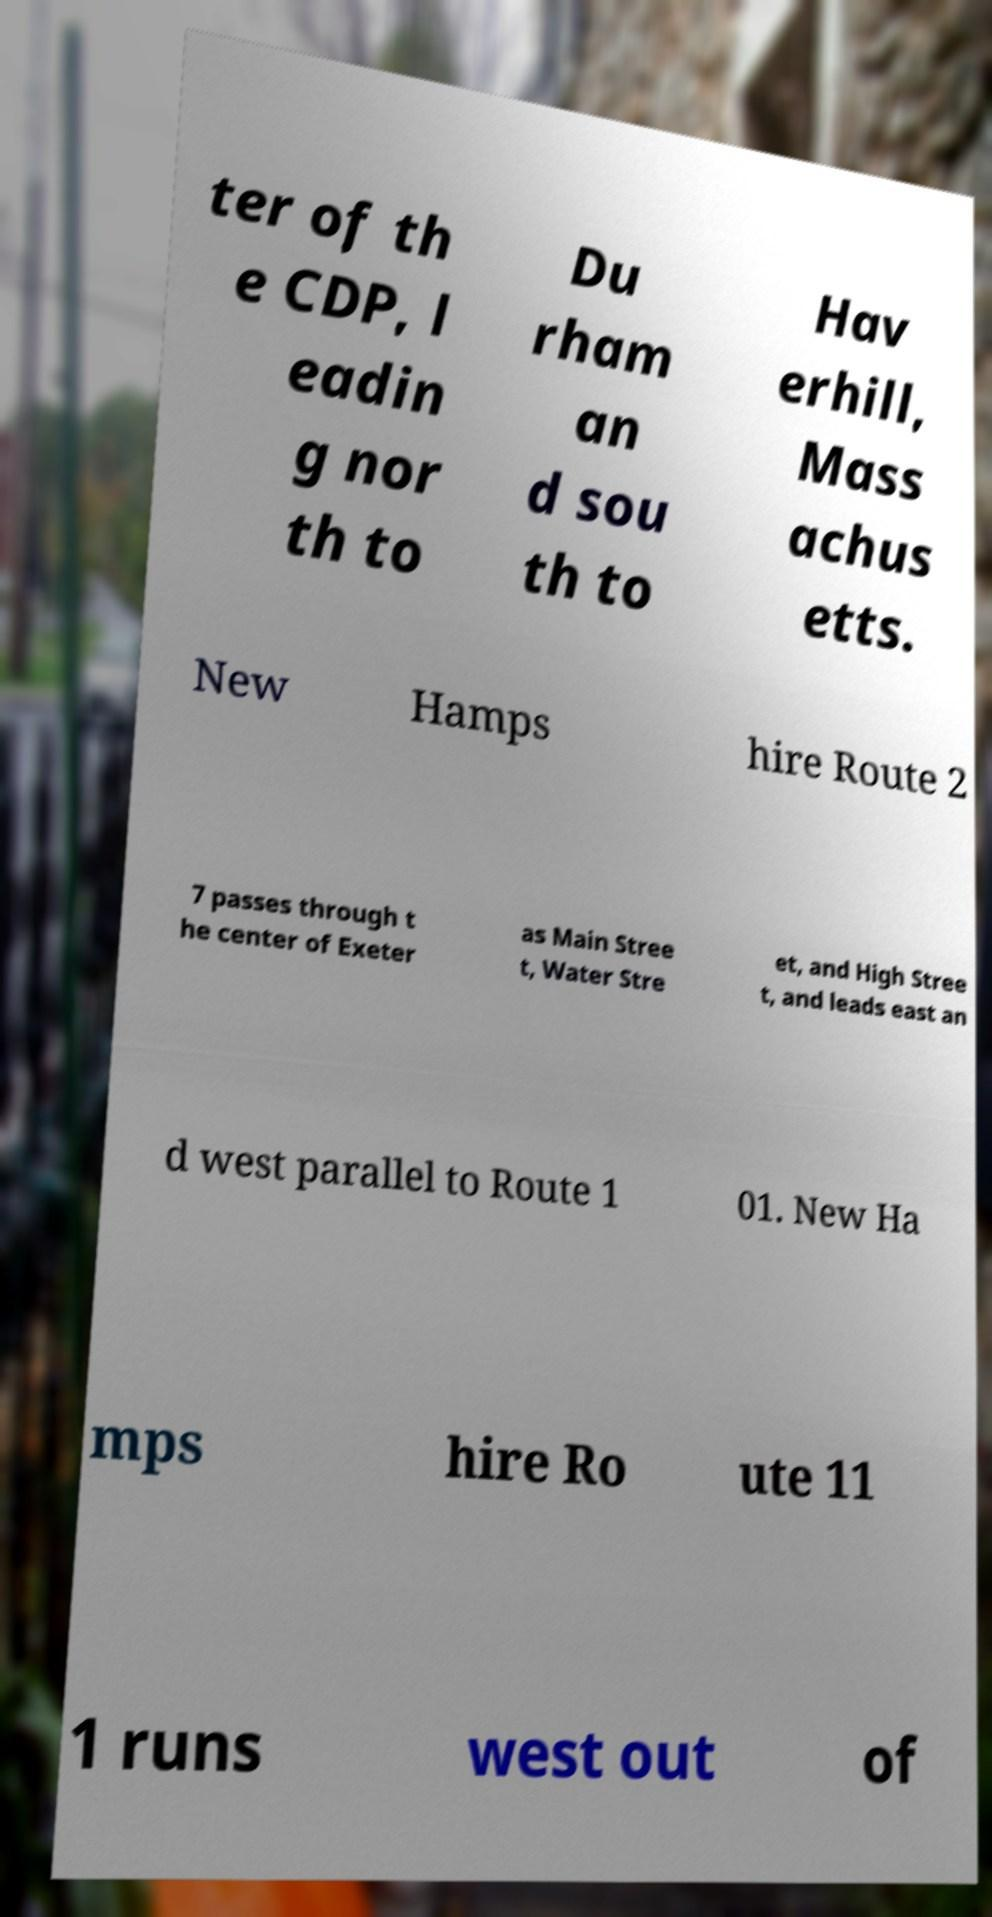What messages or text are displayed in this image? I need them in a readable, typed format. ter of th e CDP, l eadin g nor th to Du rham an d sou th to Hav erhill, Mass achus etts. New Hamps hire Route 2 7 passes through t he center of Exeter as Main Stree t, Water Stre et, and High Stree t, and leads east an d west parallel to Route 1 01. New Ha mps hire Ro ute 11 1 runs west out of 